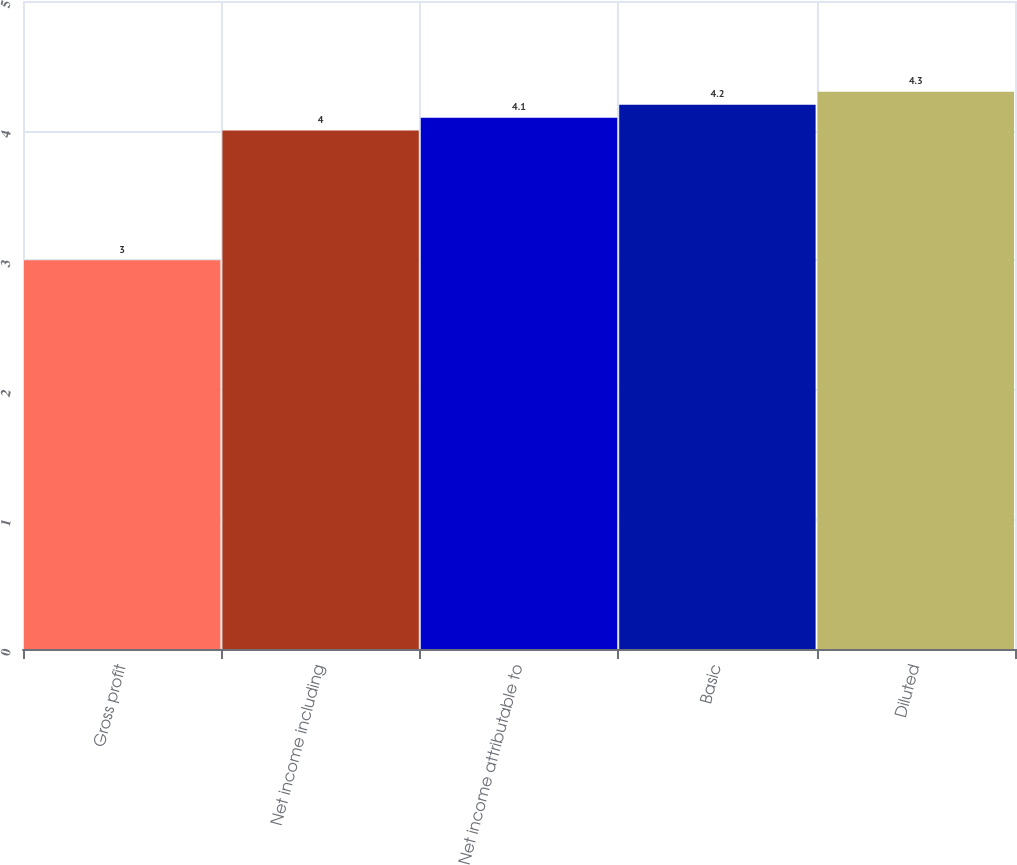Convert chart. <chart><loc_0><loc_0><loc_500><loc_500><bar_chart><fcel>Gross profit<fcel>Net income including<fcel>Net income attributable to<fcel>Basic<fcel>Diluted<nl><fcel>3<fcel>4<fcel>4.1<fcel>4.2<fcel>4.3<nl></chart> 